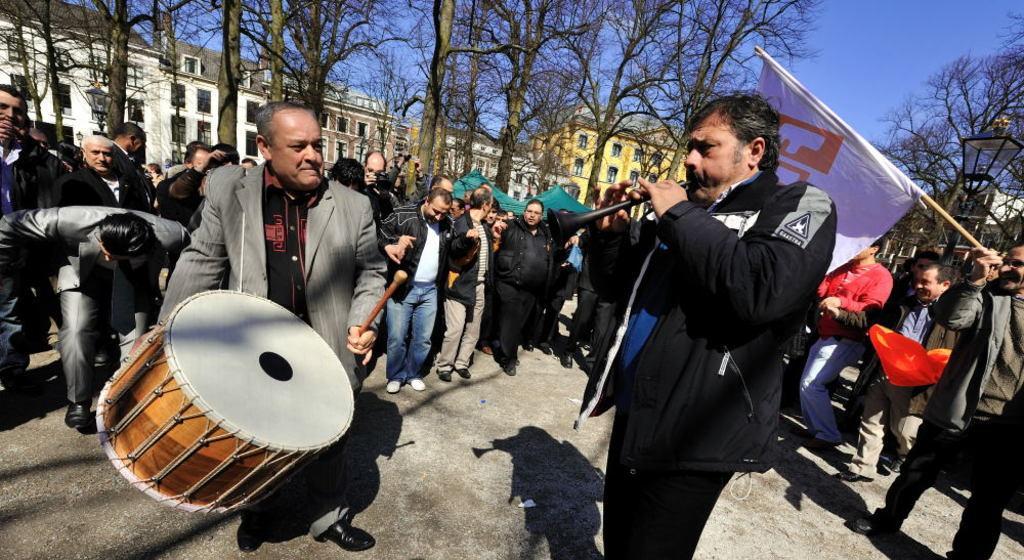Please provide a concise description of this image. The image is outside of the city. In the image there are group of people standing,dancing and playing their musical instruments. On right side there is a man holding a flag on his hand, in background there are some trees,buildings,street lights and sky is on top. 